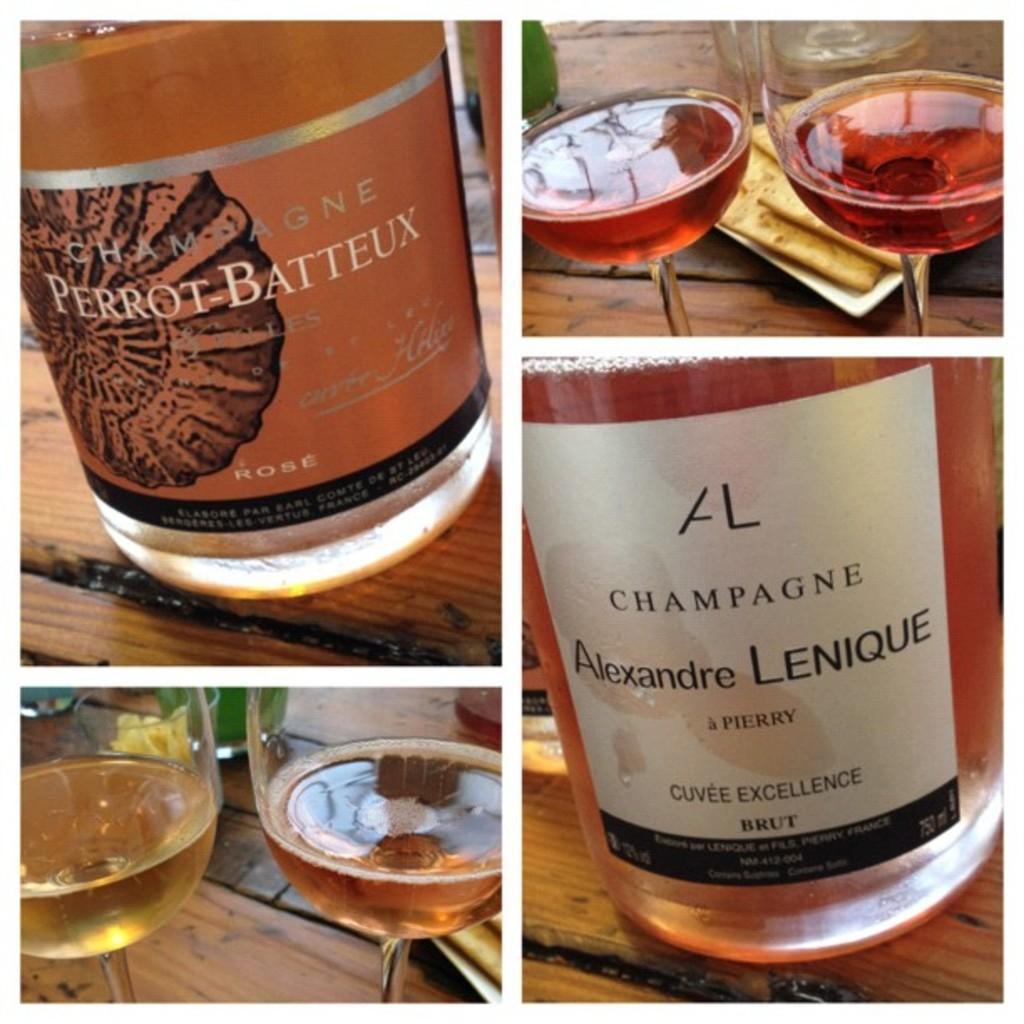<image>
Share a concise interpretation of the image provided. Two bottles of champagne from different companies, one pink and one golden in color. 